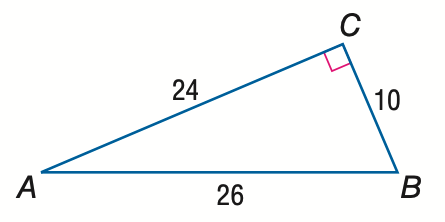Answer the mathemtical geometry problem and directly provide the correct option letter.
Question: Express the ratio of \sin B as a decimal to the nearest hundredth.
Choices: A: 0.38 B: 0.42 C: 0.92 D: 2.40 C 